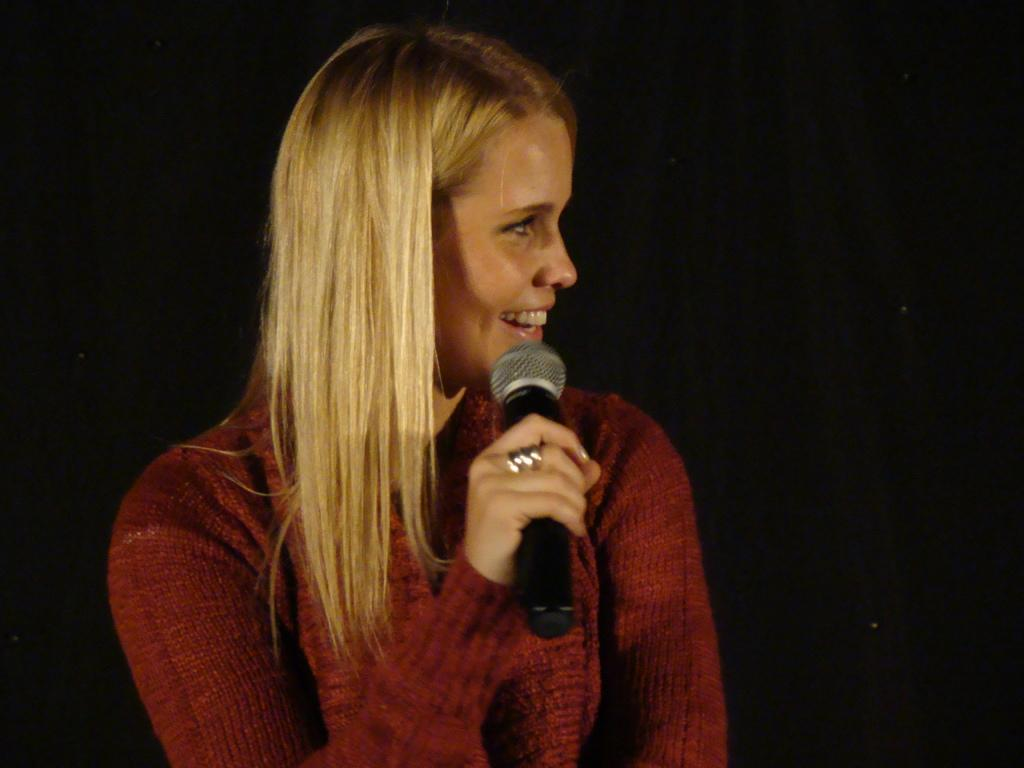What can be seen in the image? There is a person in the image. What is the person wearing? The person is wearing a sweatshirt. What is the person holding in her hand? The person is holding a microphone in her hand. In which direction is the person facing? The person has turned towards the right. What is the person's facial expression? The person is smiling. What is the color of the background in the image? There is a black background in the image. How many times does the person laugh in the image? The image does not show the person laughing; they are smiling. What is the person's birth date in the image? The image does not provide any information about the person's birth date. 